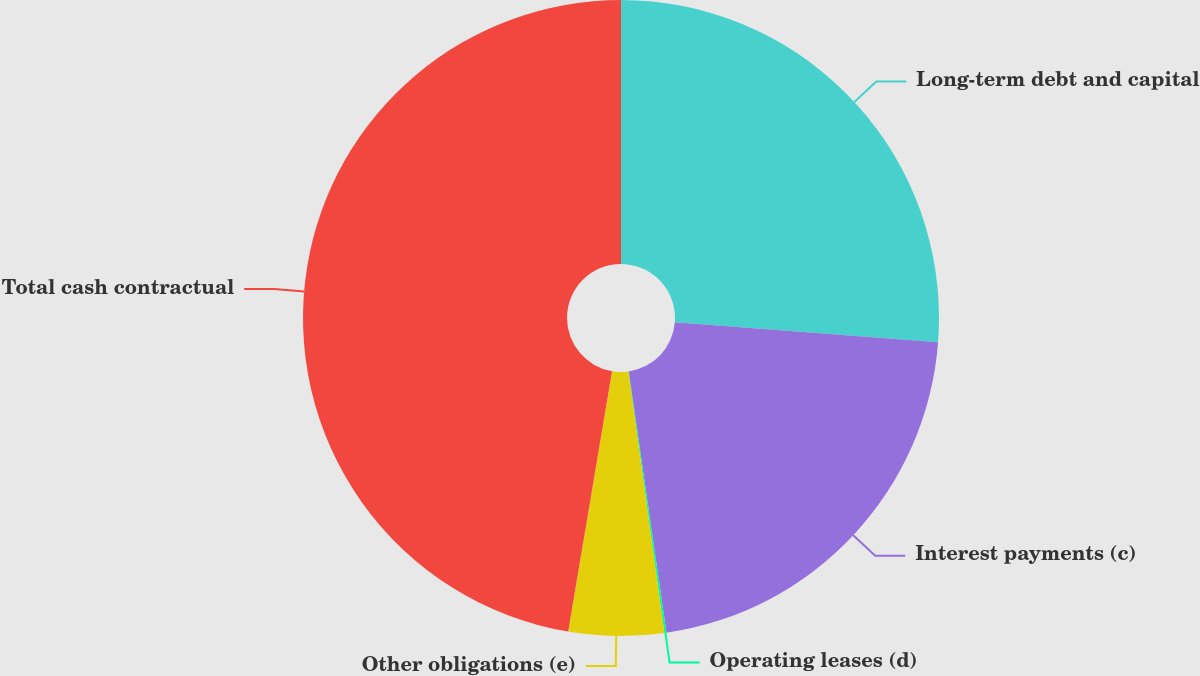Convert chart. <chart><loc_0><loc_0><loc_500><loc_500><pie_chart><fcel>Long-term debt and capital<fcel>Interest payments (c)<fcel>Operating leases (d)<fcel>Other obligations (e)<fcel>Total cash contractual<nl><fcel>26.22%<fcel>21.5%<fcel>0.11%<fcel>4.83%<fcel>47.35%<nl></chart> 